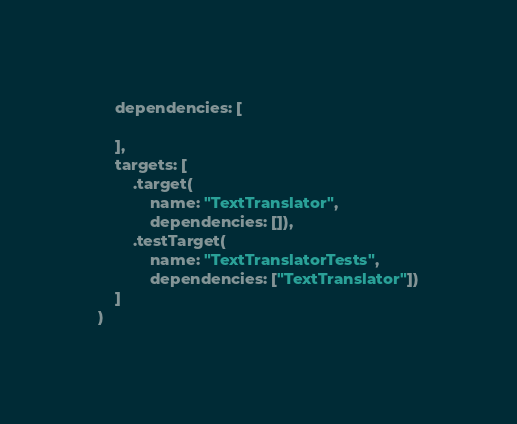Convert code to text. <code><loc_0><loc_0><loc_500><loc_500><_Swift_>    dependencies: [

    ],
    targets: [
        .target(
            name: "TextTranslator",
            dependencies: []),
        .testTarget(
            name: "TextTranslatorTests",
            dependencies: ["TextTranslator"])
    ]
)
</code> 